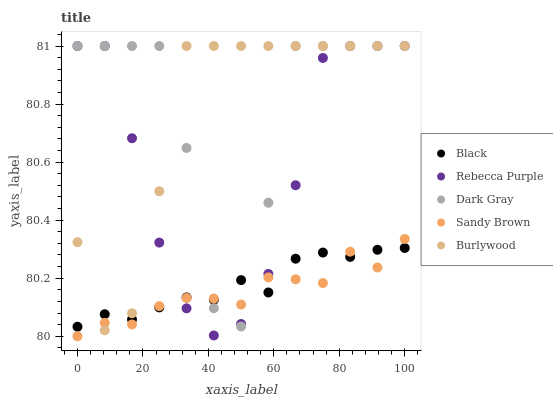Does Sandy Brown have the minimum area under the curve?
Answer yes or no. Yes. Does Burlywood have the maximum area under the curve?
Answer yes or no. Yes. Does Black have the minimum area under the curve?
Answer yes or no. No. Does Black have the maximum area under the curve?
Answer yes or no. No. Is Black the smoothest?
Answer yes or no. Yes. Is Dark Gray the roughest?
Answer yes or no. Yes. Is Sandy Brown the smoothest?
Answer yes or no. No. Is Sandy Brown the roughest?
Answer yes or no. No. Does Sandy Brown have the lowest value?
Answer yes or no. Yes. Does Black have the lowest value?
Answer yes or no. No. Does Burlywood have the highest value?
Answer yes or no. Yes. Does Sandy Brown have the highest value?
Answer yes or no. No. Does Dark Gray intersect Black?
Answer yes or no. Yes. Is Dark Gray less than Black?
Answer yes or no. No. Is Dark Gray greater than Black?
Answer yes or no. No. 